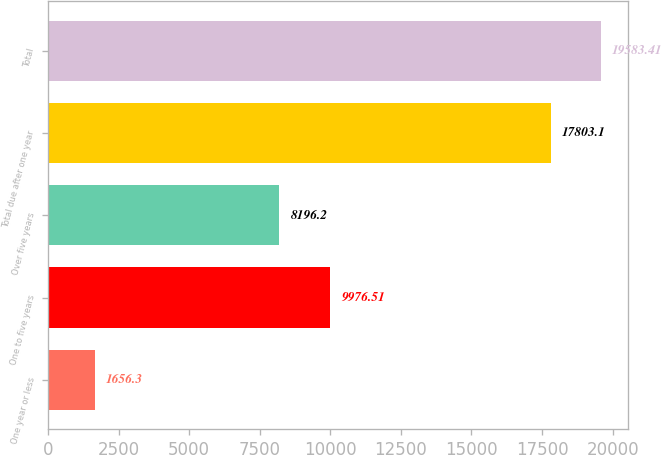<chart> <loc_0><loc_0><loc_500><loc_500><bar_chart><fcel>One year or less<fcel>One to five years<fcel>Over five years<fcel>Total due after one year<fcel>Total<nl><fcel>1656.3<fcel>9976.51<fcel>8196.2<fcel>17803.1<fcel>19583.4<nl></chart> 